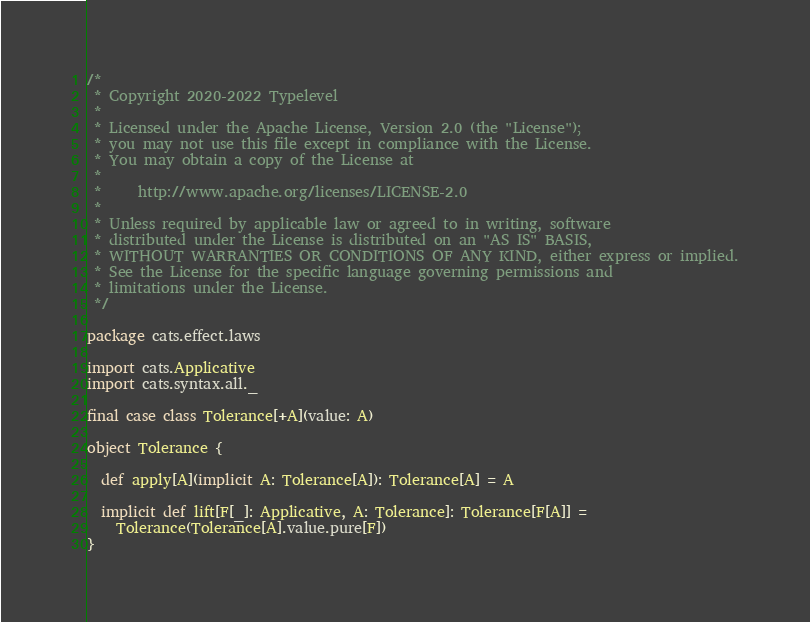<code> <loc_0><loc_0><loc_500><loc_500><_Scala_>/*
 * Copyright 2020-2022 Typelevel
 *
 * Licensed under the Apache License, Version 2.0 (the "License");
 * you may not use this file except in compliance with the License.
 * You may obtain a copy of the License at
 *
 *     http://www.apache.org/licenses/LICENSE-2.0
 *
 * Unless required by applicable law or agreed to in writing, software
 * distributed under the License is distributed on an "AS IS" BASIS,
 * WITHOUT WARRANTIES OR CONDITIONS OF ANY KIND, either express or implied.
 * See the License for the specific language governing permissions and
 * limitations under the License.
 */

package cats.effect.laws

import cats.Applicative
import cats.syntax.all._

final case class Tolerance[+A](value: A)

object Tolerance {

  def apply[A](implicit A: Tolerance[A]): Tolerance[A] = A

  implicit def lift[F[_]: Applicative, A: Tolerance]: Tolerance[F[A]] =
    Tolerance(Tolerance[A].value.pure[F])
}
</code> 